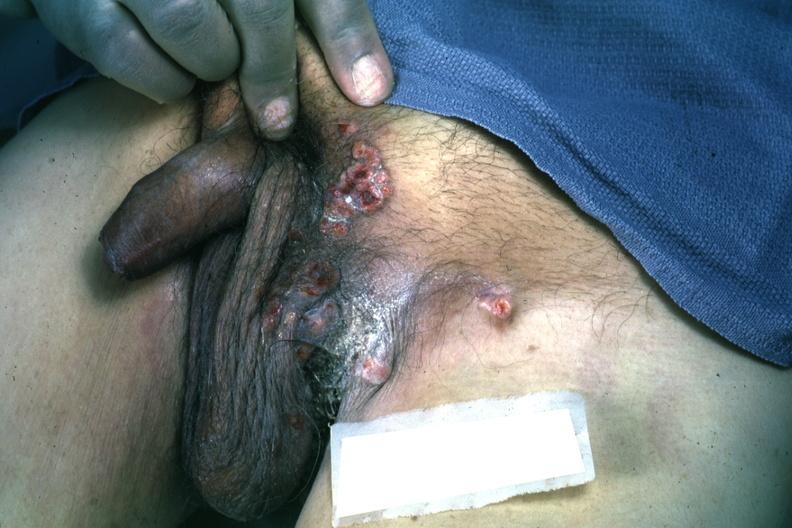what is present?
Answer the question using a single word or phrase. Inguinal area 